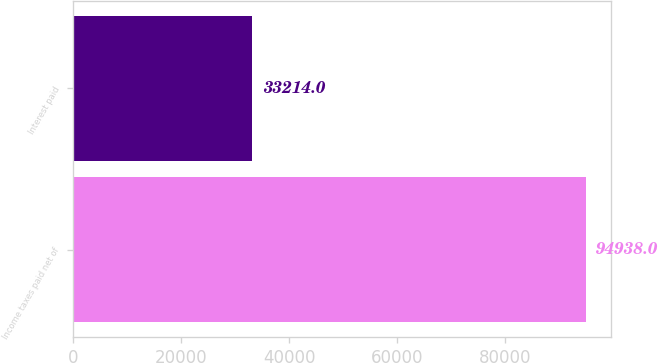Convert chart. <chart><loc_0><loc_0><loc_500><loc_500><bar_chart><fcel>Income taxes paid net of<fcel>Interest paid<nl><fcel>94938<fcel>33214<nl></chart> 